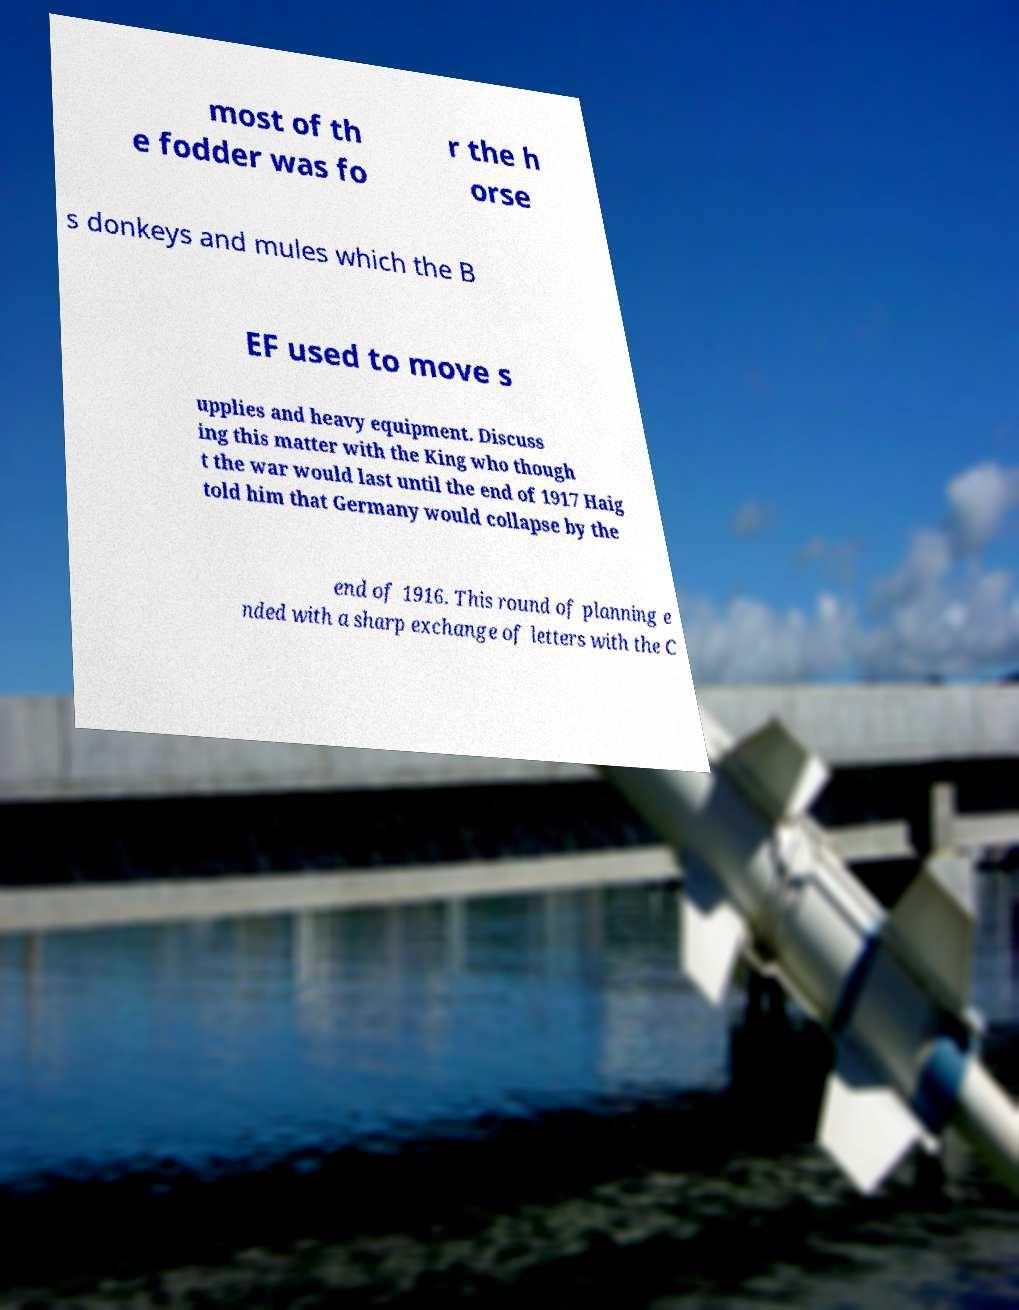I need the written content from this picture converted into text. Can you do that? most of th e fodder was fo r the h orse s donkeys and mules which the B EF used to move s upplies and heavy equipment. Discuss ing this matter with the King who though t the war would last until the end of 1917 Haig told him that Germany would collapse by the end of 1916. This round of planning e nded with a sharp exchange of letters with the C 